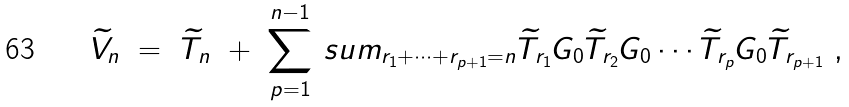Convert formula to latex. <formula><loc_0><loc_0><loc_500><loc_500>\widetilde { V } _ { n } \ = \ \widetilde { T } _ { n } \ + \ \sum _ { p = 1 } ^ { n - 1 } \, s u m _ { r _ { 1 } + \cdots + r _ { p + 1 } = n } \widetilde { T } _ { r _ { 1 } } G _ { 0 } \widetilde { T } _ { r _ { 2 } } G _ { 0 } \cdots \widetilde { T } _ { r _ { p } } G _ { 0 } \widetilde { T } _ { r _ { p + 1 } } \ ,</formula> 